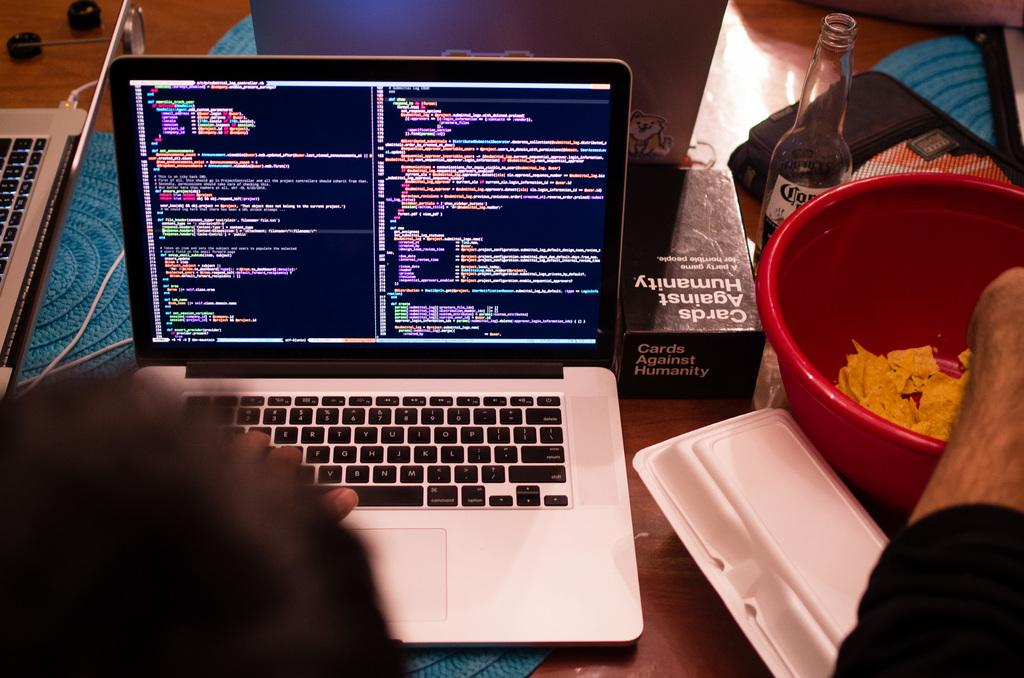<image>
Give a short and clear explanation of the subsequent image. Cards of Humanity card game next to a laptop on a table. 